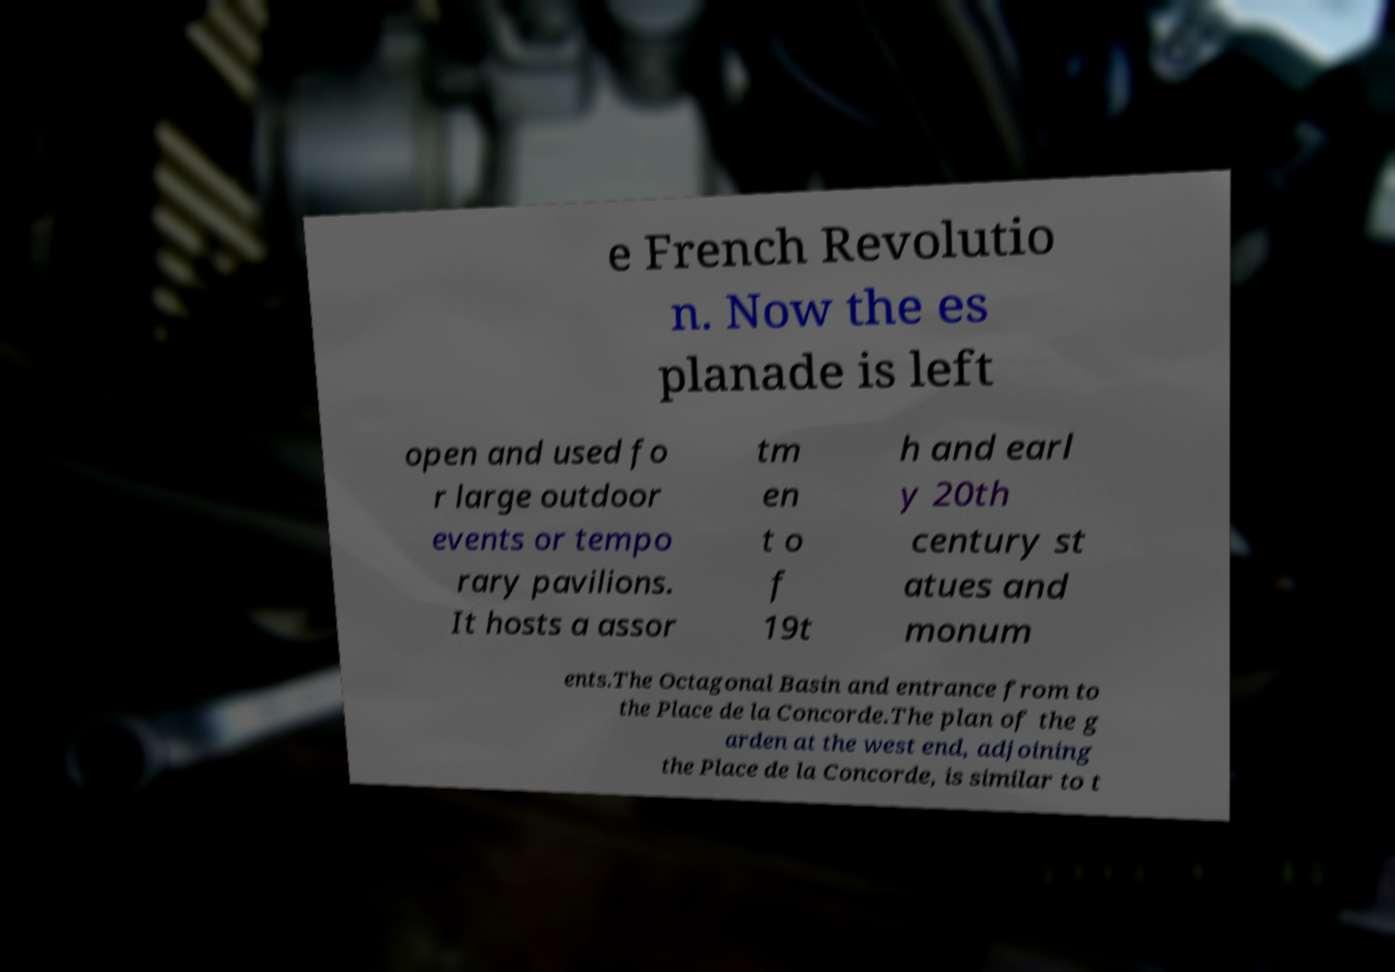Can you accurately transcribe the text from the provided image for me? e French Revolutio n. Now the es planade is left open and used fo r large outdoor events or tempo rary pavilions. It hosts a assor tm en t o f 19t h and earl y 20th century st atues and monum ents.The Octagonal Basin and entrance from to the Place de la Concorde.The plan of the g arden at the west end, adjoining the Place de la Concorde, is similar to t 